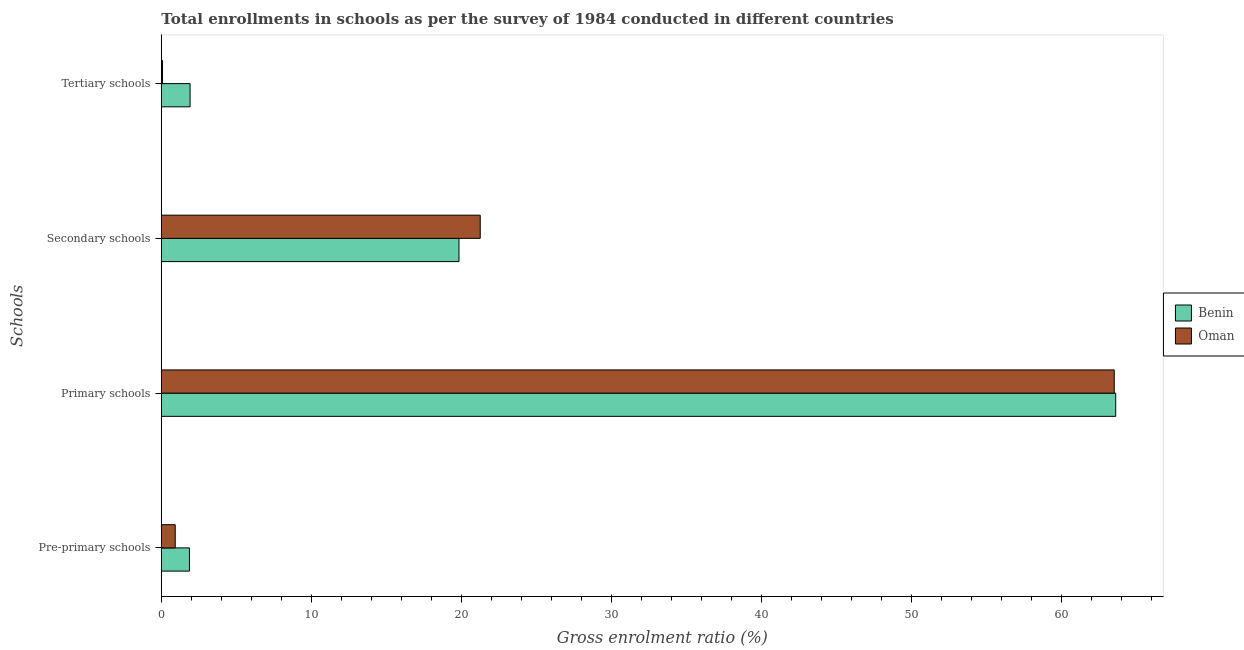How many groups of bars are there?
Keep it short and to the point. 4. Are the number of bars on each tick of the Y-axis equal?
Your answer should be compact. Yes. How many bars are there on the 2nd tick from the top?
Your answer should be compact. 2. How many bars are there on the 2nd tick from the bottom?
Your answer should be compact. 2. What is the label of the 3rd group of bars from the top?
Your response must be concise. Primary schools. What is the gross enrolment ratio in secondary schools in Oman?
Your response must be concise. 21.26. Across all countries, what is the maximum gross enrolment ratio in primary schools?
Your response must be concise. 63.62. Across all countries, what is the minimum gross enrolment ratio in pre-primary schools?
Your response must be concise. 0.93. In which country was the gross enrolment ratio in secondary schools maximum?
Your answer should be very brief. Oman. In which country was the gross enrolment ratio in secondary schools minimum?
Keep it short and to the point. Benin. What is the total gross enrolment ratio in pre-primary schools in the graph?
Your response must be concise. 2.8. What is the difference between the gross enrolment ratio in pre-primary schools in Oman and that in Benin?
Ensure brevity in your answer.  -0.95. What is the difference between the gross enrolment ratio in primary schools in Benin and the gross enrolment ratio in pre-primary schools in Oman?
Your response must be concise. 62.69. What is the average gross enrolment ratio in primary schools per country?
Your response must be concise. 63.57. What is the difference between the gross enrolment ratio in pre-primary schools and gross enrolment ratio in primary schools in Oman?
Offer a very short reply. -62.59. What is the ratio of the gross enrolment ratio in secondary schools in Benin to that in Oman?
Provide a succinct answer. 0.93. Is the gross enrolment ratio in tertiary schools in Oman less than that in Benin?
Your answer should be compact. Yes. Is the difference between the gross enrolment ratio in tertiary schools in Oman and Benin greater than the difference between the gross enrolment ratio in secondary schools in Oman and Benin?
Provide a short and direct response. No. What is the difference between the highest and the second highest gross enrolment ratio in primary schools?
Offer a terse response. 0.1. What is the difference between the highest and the lowest gross enrolment ratio in primary schools?
Provide a succinct answer. 0.1. Is the sum of the gross enrolment ratio in secondary schools in Oman and Benin greater than the maximum gross enrolment ratio in primary schools across all countries?
Offer a very short reply. No. What does the 1st bar from the top in Tertiary schools represents?
Your answer should be very brief. Oman. What does the 2nd bar from the bottom in Primary schools represents?
Provide a short and direct response. Oman. Are all the bars in the graph horizontal?
Offer a terse response. Yes. How many countries are there in the graph?
Your answer should be very brief. 2. Are the values on the major ticks of X-axis written in scientific E-notation?
Your response must be concise. No. Does the graph contain any zero values?
Your answer should be compact. No. Does the graph contain grids?
Make the answer very short. No. Where does the legend appear in the graph?
Ensure brevity in your answer.  Center right. What is the title of the graph?
Provide a succinct answer. Total enrollments in schools as per the survey of 1984 conducted in different countries. Does "Malawi" appear as one of the legend labels in the graph?
Your response must be concise. No. What is the label or title of the Y-axis?
Offer a terse response. Schools. What is the Gross enrolment ratio (%) in Benin in Pre-primary schools?
Your answer should be very brief. 1.88. What is the Gross enrolment ratio (%) in Oman in Pre-primary schools?
Ensure brevity in your answer.  0.93. What is the Gross enrolment ratio (%) in Benin in Primary schools?
Keep it short and to the point. 63.62. What is the Gross enrolment ratio (%) of Oman in Primary schools?
Your response must be concise. 63.52. What is the Gross enrolment ratio (%) of Benin in Secondary schools?
Keep it short and to the point. 19.84. What is the Gross enrolment ratio (%) of Oman in Secondary schools?
Provide a short and direct response. 21.26. What is the Gross enrolment ratio (%) of Benin in Tertiary schools?
Your answer should be compact. 1.92. What is the Gross enrolment ratio (%) of Oman in Tertiary schools?
Provide a succinct answer. 0.08. Across all Schools, what is the maximum Gross enrolment ratio (%) in Benin?
Ensure brevity in your answer.  63.62. Across all Schools, what is the maximum Gross enrolment ratio (%) in Oman?
Provide a short and direct response. 63.52. Across all Schools, what is the minimum Gross enrolment ratio (%) of Benin?
Offer a very short reply. 1.88. Across all Schools, what is the minimum Gross enrolment ratio (%) in Oman?
Your answer should be compact. 0.08. What is the total Gross enrolment ratio (%) in Benin in the graph?
Offer a terse response. 87.25. What is the total Gross enrolment ratio (%) of Oman in the graph?
Provide a succinct answer. 85.79. What is the difference between the Gross enrolment ratio (%) of Benin in Pre-primary schools and that in Primary schools?
Make the answer very short. -61.74. What is the difference between the Gross enrolment ratio (%) in Oman in Pre-primary schools and that in Primary schools?
Offer a very short reply. -62.59. What is the difference between the Gross enrolment ratio (%) in Benin in Pre-primary schools and that in Secondary schools?
Your answer should be compact. -17.97. What is the difference between the Gross enrolment ratio (%) of Oman in Pre-primary schools and that in Secondary schools?
Offer a very short reply. -20.33. What is the difference between the Gross enrolment ratio (%) in Benin in Pre-primary schools and that in Tertiary schools?
Offer a very short reply. -0.04. What is the difference between the Gross enrolment ratio (%) in Oman in Pre-primary schools and that in Tertiary schools?
Offer a very short reply. 0.85. What is the difference between the Gross enrolment ratio (%) of Benin in Primary schools and that in Secondary schools?
Your response must be concise. 43.78. What is the difference between the Gross enrolment ratio (%) of Oman in Primary schools and that in Secondary schools?
Offer a very short reply. 42.26. What is the difference between the Gross enrolment ratio (%) of Benin in Primary schools and that in Tertiary schools?
Your answer should be compact. 61.7. What is the difference between the Gross enrolment ratio (%) in Oman in Primary schools and that in Tertiary schools?
Provide a succinct answer. 63.44. What is the difference between the Gross enrolment ratio (%) of Benin in Secondary schools and that in Tertiary schools?
Ensure brevity in your answer.  17.92. What is the difference between the Gross enrolment ratio (%) of Oman in Secondary schools and that in Tertiary schools?
Your answer should be compact. 21.18. What is the difference between the Gross enrolment ratio (%) of Benin in Pre-primary schools and the Gross enrolment ratio (%) of Oman in Primary schools?
Give a very brief answer. -61.64. What is the difference between the Gross enrolment ratio (%) in Benin in Pre-primary schools and the Gross enrolment ratio (%) in Oman in Secondary schools?
Your answer should be compact. -19.38. What is the difference between the Gross enrolment ratio (%) in Benin in Pre-primary schools and the Gross enrolment ratio (%) in Oman in Tertiary schools?
Your response must be concise. 1.8. What is the difference between the Gross enrolment ratio (%) of Benin in Primary schools and the Gross enrolment ratio (%) of Oman in Secondary schools?
Give a very brief answer. 42.36. What is the difference between the Gross enrolment ratio (%) of Benin in Primary schools and the Gross enrolment ratio (%) of Oman in Tertiary schools?
Offer a very short reply. 63.54. What is the difference between the Gross enrolment ratio (%) of Benin in Secondary schools and the Gross enrolment ratio (%) of Oman in Tertiary schools?
Provide a short and direct response. 19.76. What is the average Gross enrolment ratio (%) of Benin per Schools?
Offer a very short reply. 21.81. What is the average Gross enrolment ratio (%) of Oman per Schools?
Keep it short and to the point. 21.45. What is the difference between the Gross enrolment ratio (%) of Benin and Gross enrolment ratio (%) of Oman in Pre-primary schools?
Keep it short and to the point. 0.95. What is the difference between the Gross enrolment ratio (%) in Benin and Gross enrolment ratio (%) in Oman in Primary schools?
Provide a succinct answer. 0.1. What is the difference between the Gross enrolment ratio (%) of Benin and Gross enrolment ratio (%) of Oman in Secondary schools?
Keep it short and to the point. -1.42. What is the difference between the Gross enrolment ratio (%) in Benin and Gross enrolment ratio (%) in Oman in Tertiary schools?
Keep it short and to the point. 1.84. What is the ratio of the Gross enrolment ratio (%) in Benin in Pre-primary schools to that in Primary schools?
Ensure brevity in your answer.  0.03. What is the ratio of the Gross enrolment ratio (%) in Oman in Pre-primary schools to that in Primary schools?
Your answer should be compact. 0.01. What is the ratio of the Gross enrolment ratio (%) of Benin in Pre-primary schools to that in Secondary schools?
Your response must be concise. 0.09. What is the ratio of the Gross enrolment ratio (%) of Oman in Pre-primary schools to that in Secondary schools?
Your response must be concise. 0.04. What is the ratio of the Gross enrolment ratio (%) of Benin in Pre-primary schools to that in Tertiary schools?
Your answer should be compact. 0.98. What is the ratio of the Gross enrolment ratio (%) of Oman in Pre-primary schools to that in Tertiary schools?
Make the answer very short. 11.5. What is the ratio of the Gross enrolment ratio (%) in Benin in Primary schools to that in Secondary schools?
Give a very brief answer. 3.21. What is the ratio of the Gross enrolment ratio (%) in Oman in Primary schools to that in Secondary schools?
Make the answer very short. 2.99. What is the ratio of the Gross enrolment ratio (%) in Benin in Primary schools to that in Tertiary schools?
Offer a terse response. 33.18. What is the ratio of the Gross enrolment ratio (%) in Oman in Primary schools to that in Tertiary schools?
Your answer should be very brief. 788.48. What is the ratio of the Gross enrolment ratio (%) in Benin in Secondary schools to that in Tertiary schools?
Keep it short and to the point. 10.35. What is the ratio of the Gross enrolment ratio (%) in Oman in Secondary schools to that in Tertiary schools?
Offer a very short reply. 263.89. What is the difference between the highest and the second highest Gross enrolment ratio (%) in Benin?
Offer a very short reply. 43.78. What is the difference between the highest and the second highest Gross enrolment ratio (%) of Oman?
Ensure brevity in your answer.  42.26. What is the difference between the highest and the lowest Gross enrolment ratio (%) of Benin?
Keep it short and to the point. 61.74. What is the difference between the highest and the lowest Gross enrolment ratio (%) in Oman?
Your answer should be very brief. 63.44. 